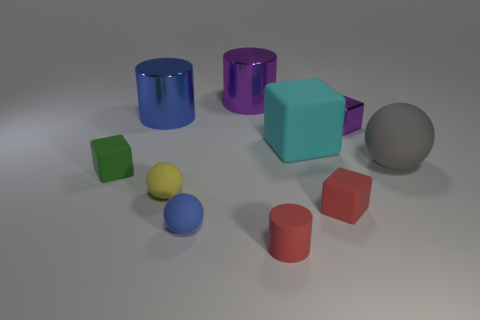What is the color of the large metal object that is on the left side of the blue object in front of the large gray thing?
Offer a very short reply. Blue. What number of other objects are the same material as the big gray object?
Give a very brief answer. 6. Are there the same number of red blocks that are to the right of the small purple metallic object and gray rubber balls?
Ensure brevity in your answer.  No. What is the small red object in front of the tiny matte sphere in front of the red object to the right of the tiny red cylinder made of?
Offer a very short reply. Rubber. The small block that is behind the green matte thing is what color?
Ensure brevity in your answer.  Purple. Are there any other things that have the same shape as the small purple metal object?
Make the answer very short. Yes. There is a purple shiny thing that is in front of the big blue thing behind the rubber cylinder; what size is it?
Your response must be concise. Small. Is the number of small red things left of the small yellow rubber object the same as the number of cyan matte things that are behind the red matte cylinder?
Your answer should be compact. No. Are there any other things that are the same size as the metallic cube?
Keep it short and to the point. Yes. There is a small cylinder that is the same material as the large ball; what color is it?
Give a very brief answer. Red. 